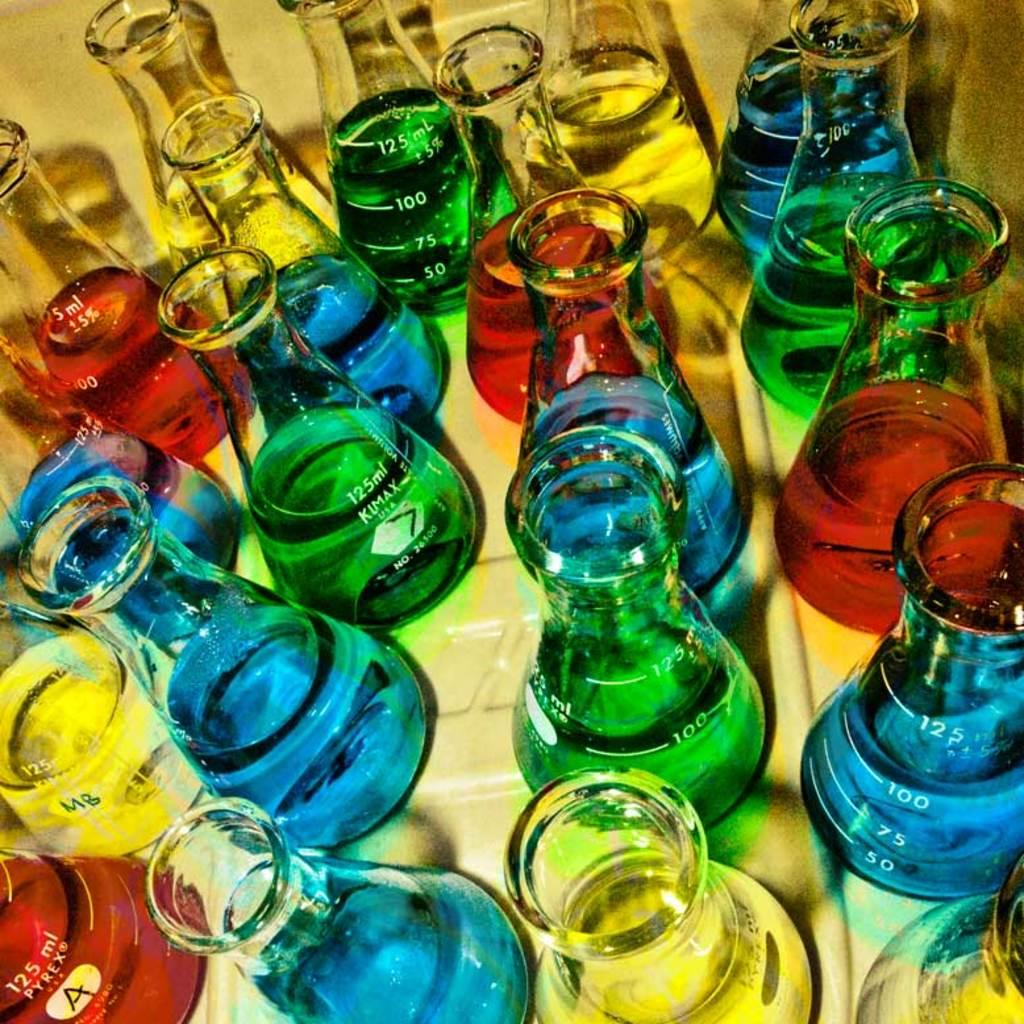Provide a one-sentence caption for the provided image. Many 125ml beakers are filled with blue, green, yellow, and red colored liquids. 